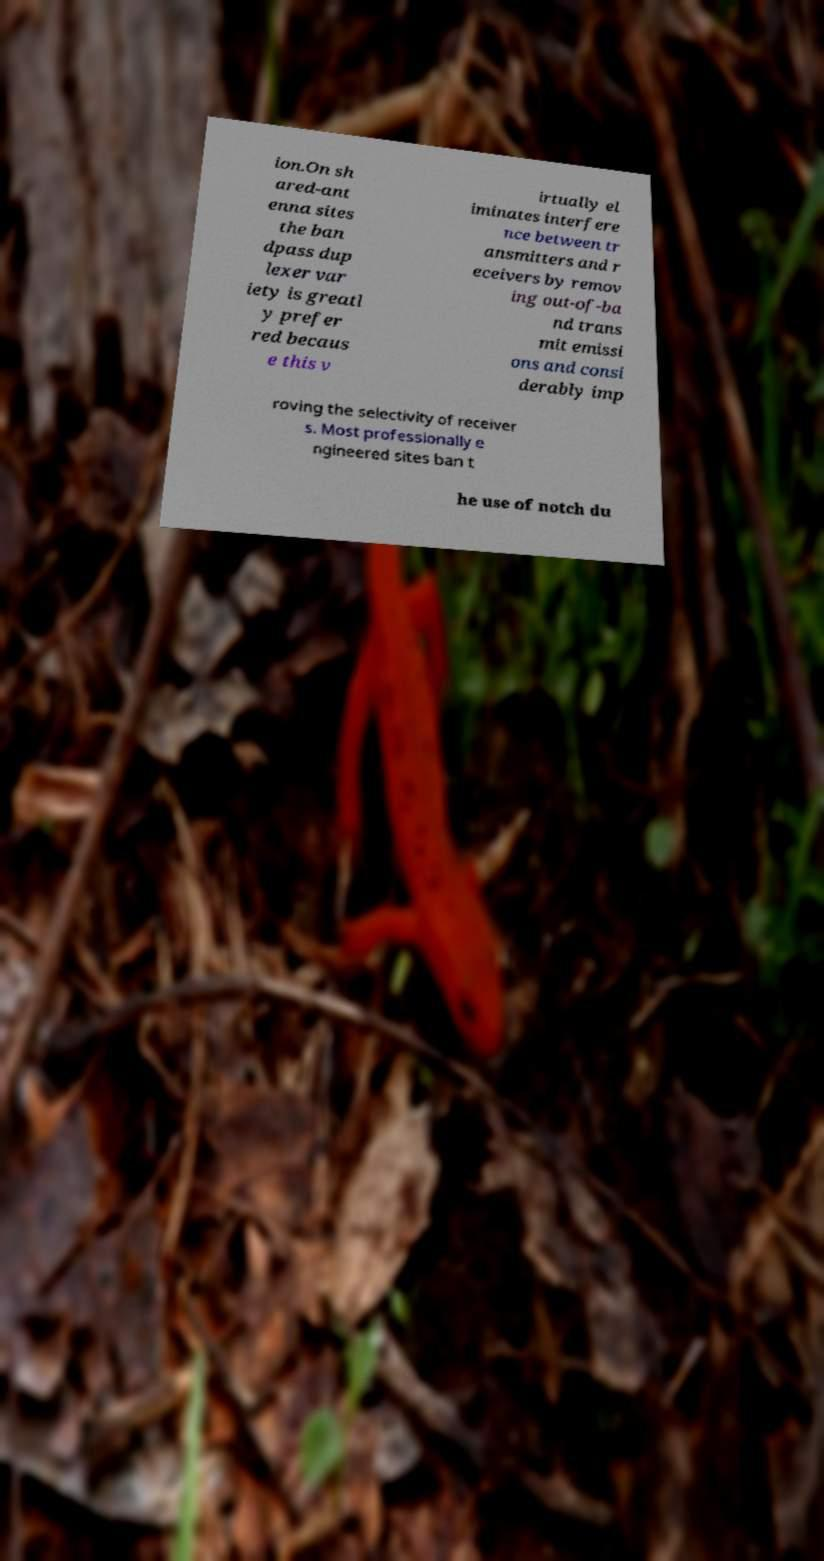There's text embedded in this image that I need extracted. Can you transcribe it verbatim? ion.On sh ared-ant enna sites the ban dpass dup lexer var iety is greatl y prefer red becaus e this v irtually el iminates interfere nce between tr ansmitters and r eceivers by remov ing out-of-ba nd trans mit emissi ons and consi derably imp roving the selectivity of receiver s. Most professionally e ngineered sites ban t he use of notch du 